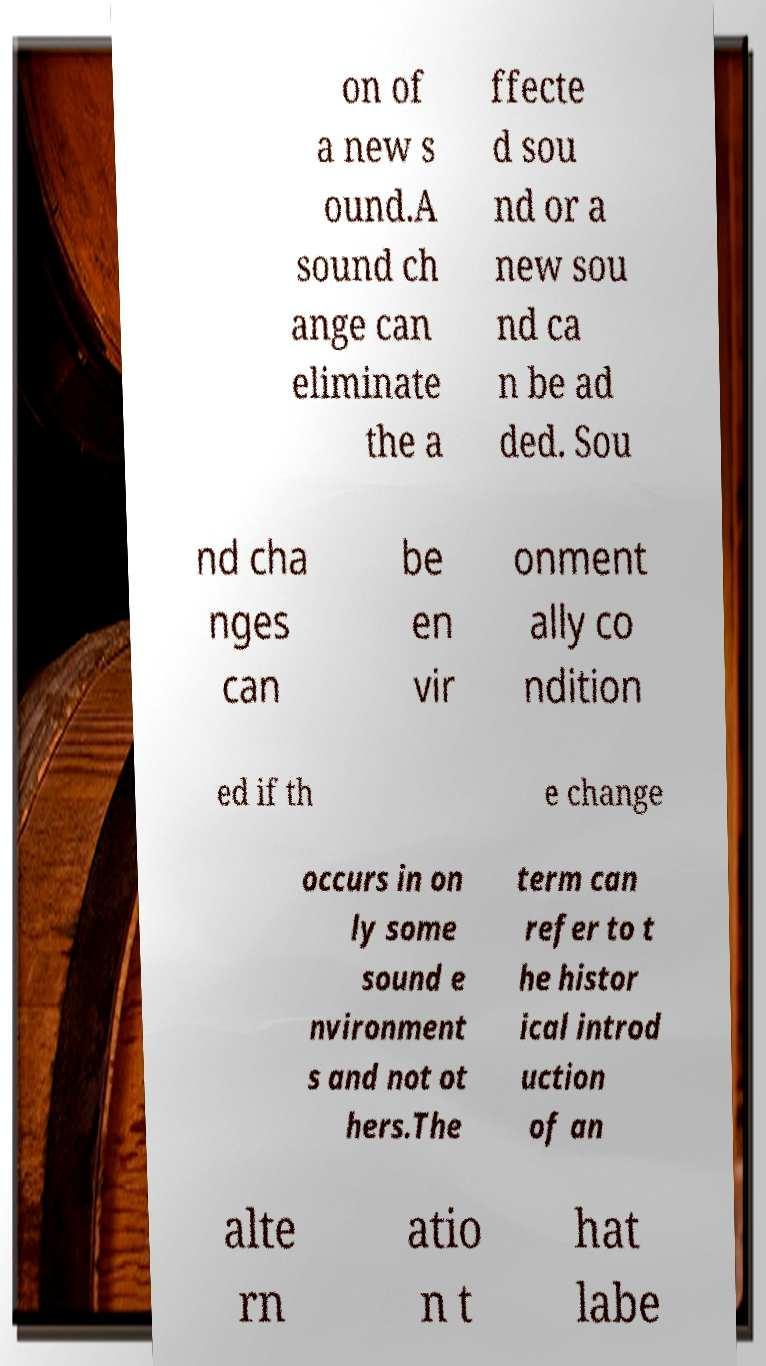What messages or text are displayed in this image? I need them in a readable, typed format. on of a new s ound.A sound ch ange can eliminate the a ffecte d sou nd or a new sou nd ca n be ad ded. Sou nd cha nges can be en vir onment ally co ndition ed if th e change occurs in on ly some sound e nvironment s and not ot hers.The term can refer to t he histor ical introd uction of an alte rn atio n t hat labe 